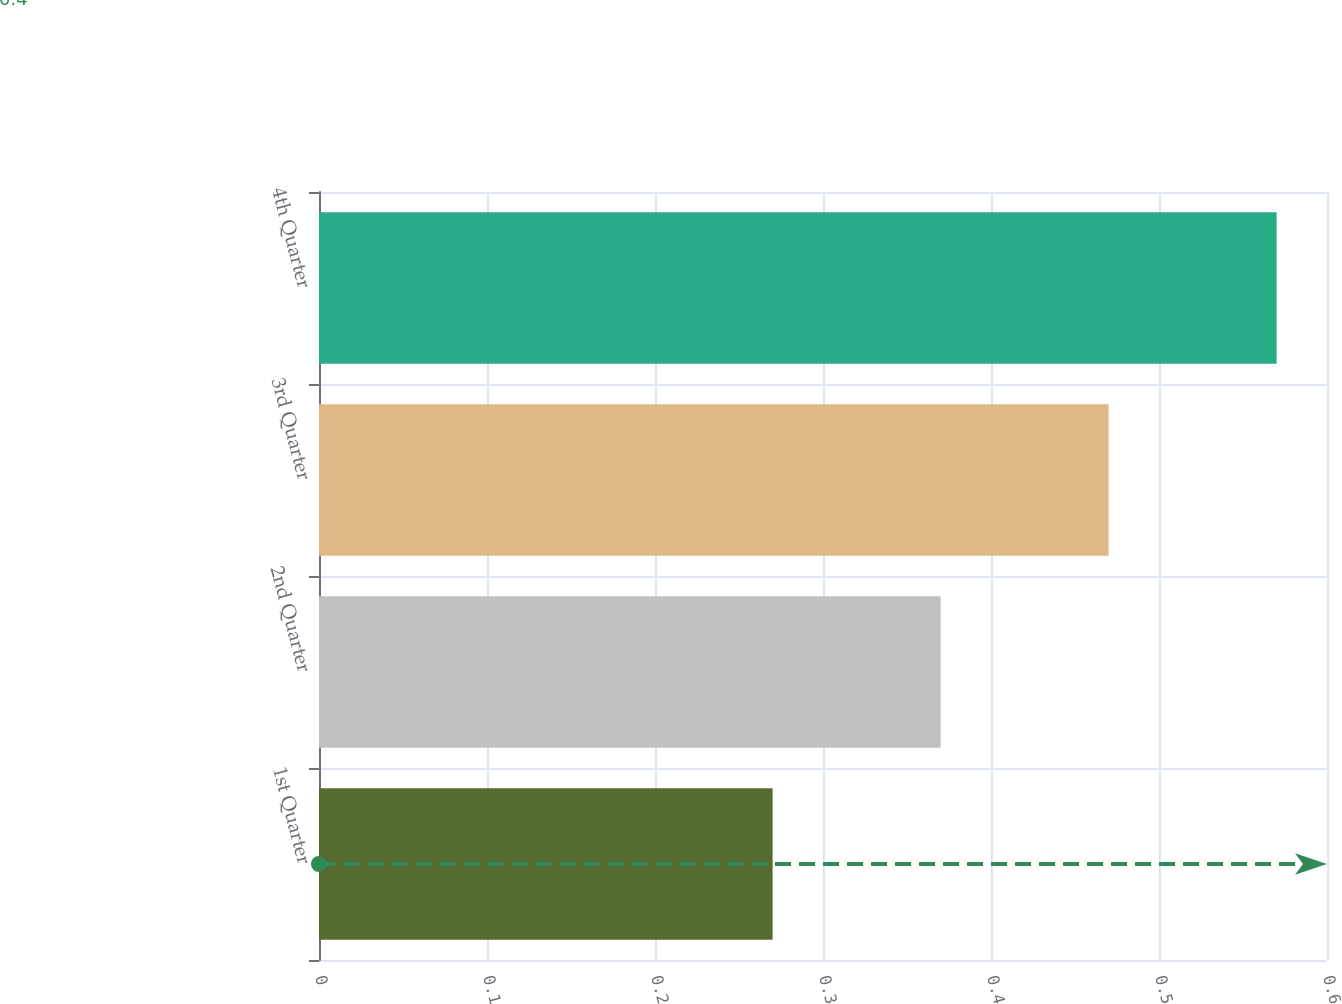<chart> <loc_0><loc_0><loc_500><loc_500><bar_chart><fcel>1st Quarter<fcel>2nd Quarter<fcel>3rd Quarter<fcel>4th Quarter<nl><fcel>0.27<fcel>0.37<fcel>0.47<fcel>0.57<nl></chart> 